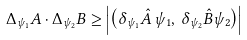<formula> <loc_0><loc_0><loc_500><loc_500>\Delta _ { \psi _ { 1 } } A \cdot \Delta _ { \psi _ { 2 } } B \geq \left | { \left ( { \delta _ { \psi _ { 1 } } \hat { A } \, \psi _ { 1 } , \, \delta _ { \psi _ { 2 } } \hat { B } \psi _ { 2 } } \right ) } \right |</formula> 